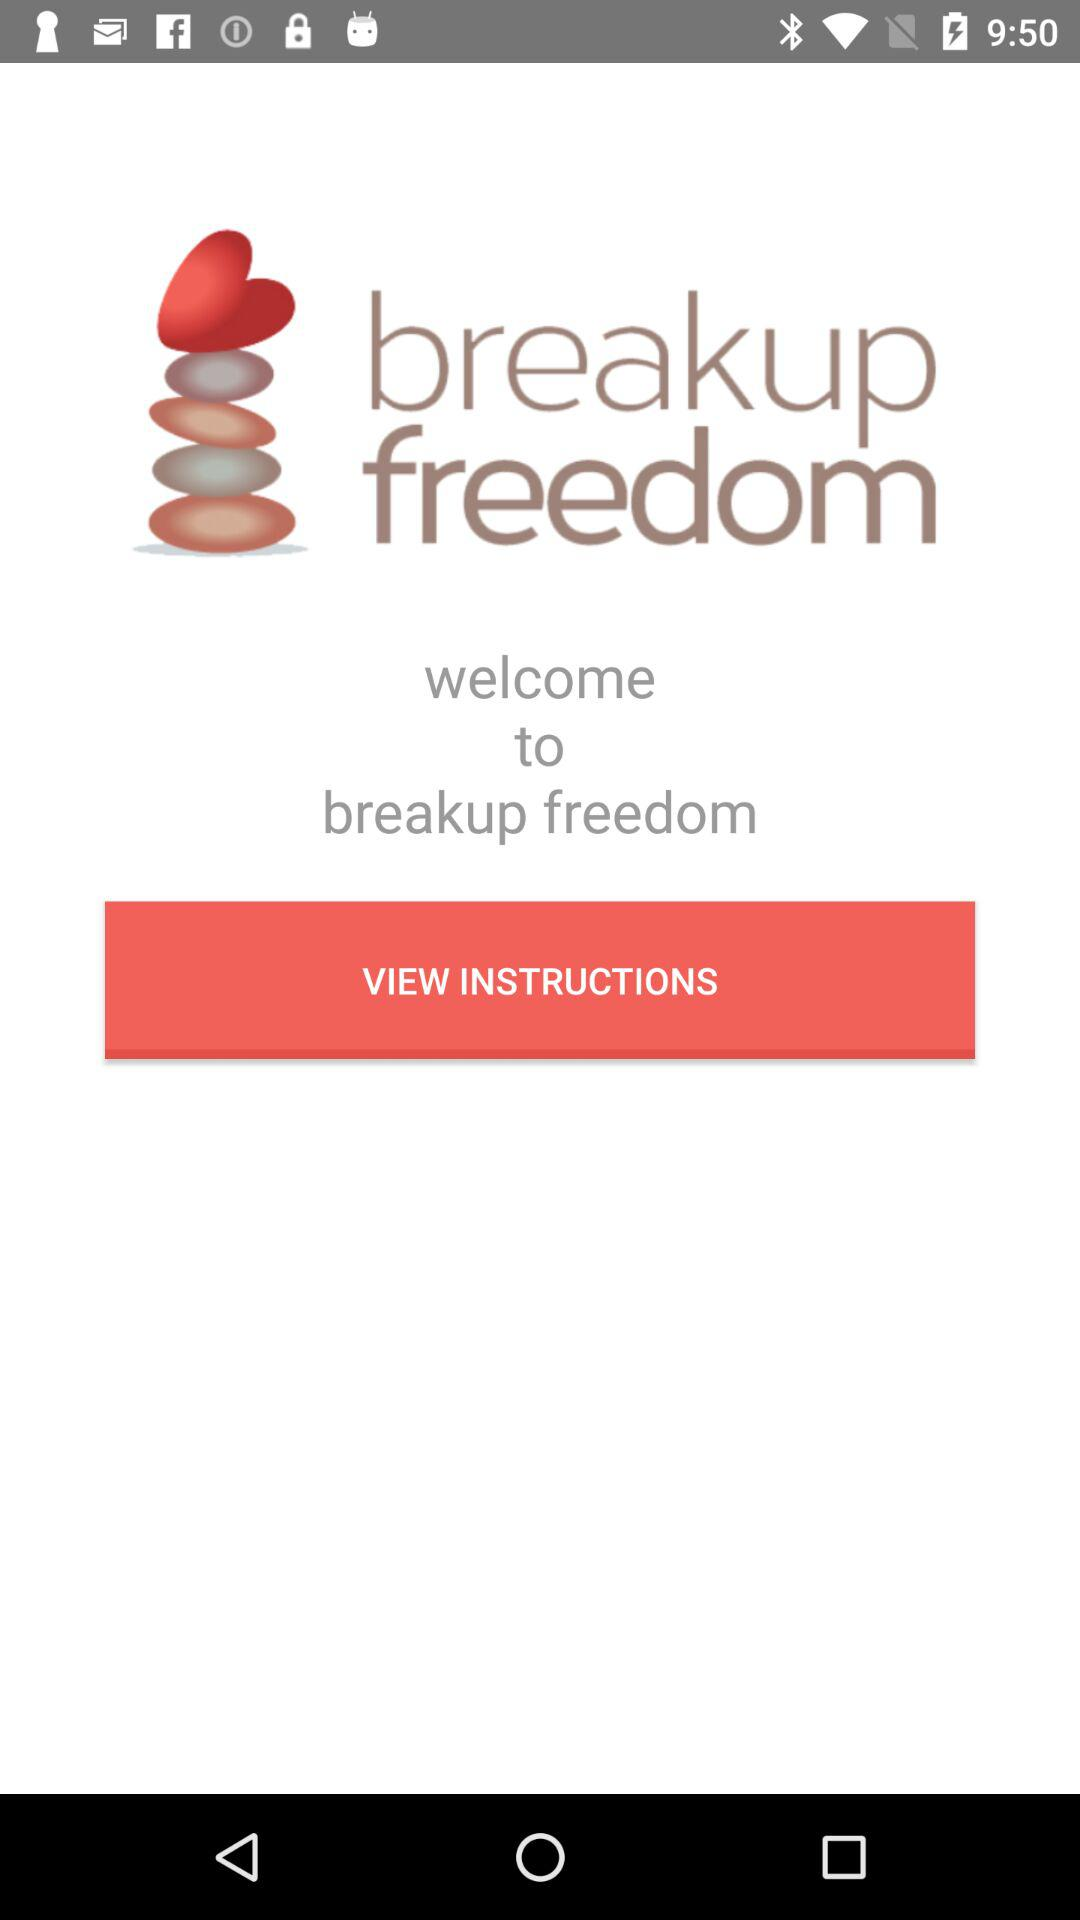With what applications can we share "breakup freedom"?
When the provided information is insufficient, respond with <no answer>. <no answer> 